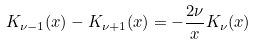Convert formula to latex. <formula><loc_0><loc_0><loc_500><loc_500>K _ { \nu - 1 } ( x ) - K _ { \nu + 1 } ( x ) = - \frac { 2 \nu } { x } K _ { \nu } ( x )</formula> 